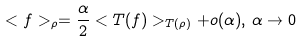Convert formula to latex. <formula><loc_0><loc_0><loc_500><loc_500>< f > _ { \rho } = \frac { \alpha } { 2 } < T ( f ) > _ { T ( \rho ) } + o ( \alpha ) , \, \alpha \to 0</formula> 